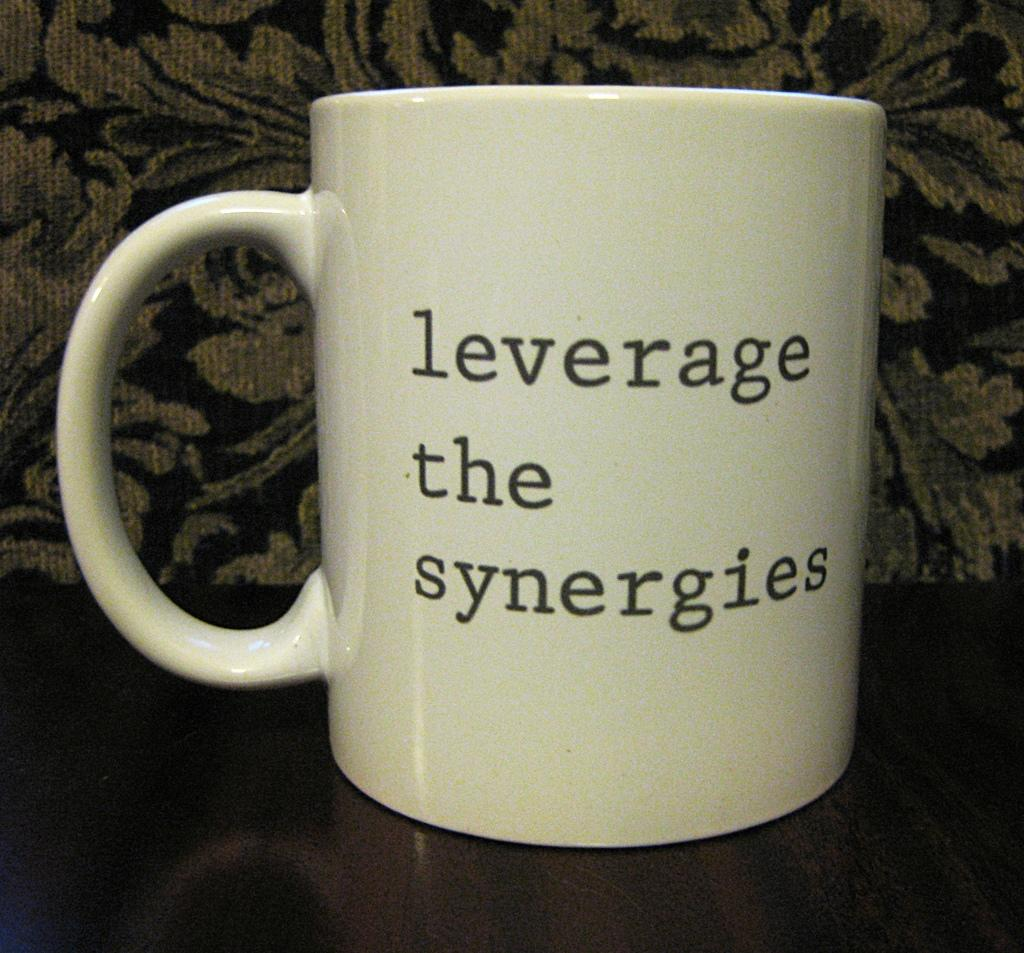<image>
Present a compact description of the photo's key features. a white mug with black letters that say Leverage the Synergies 